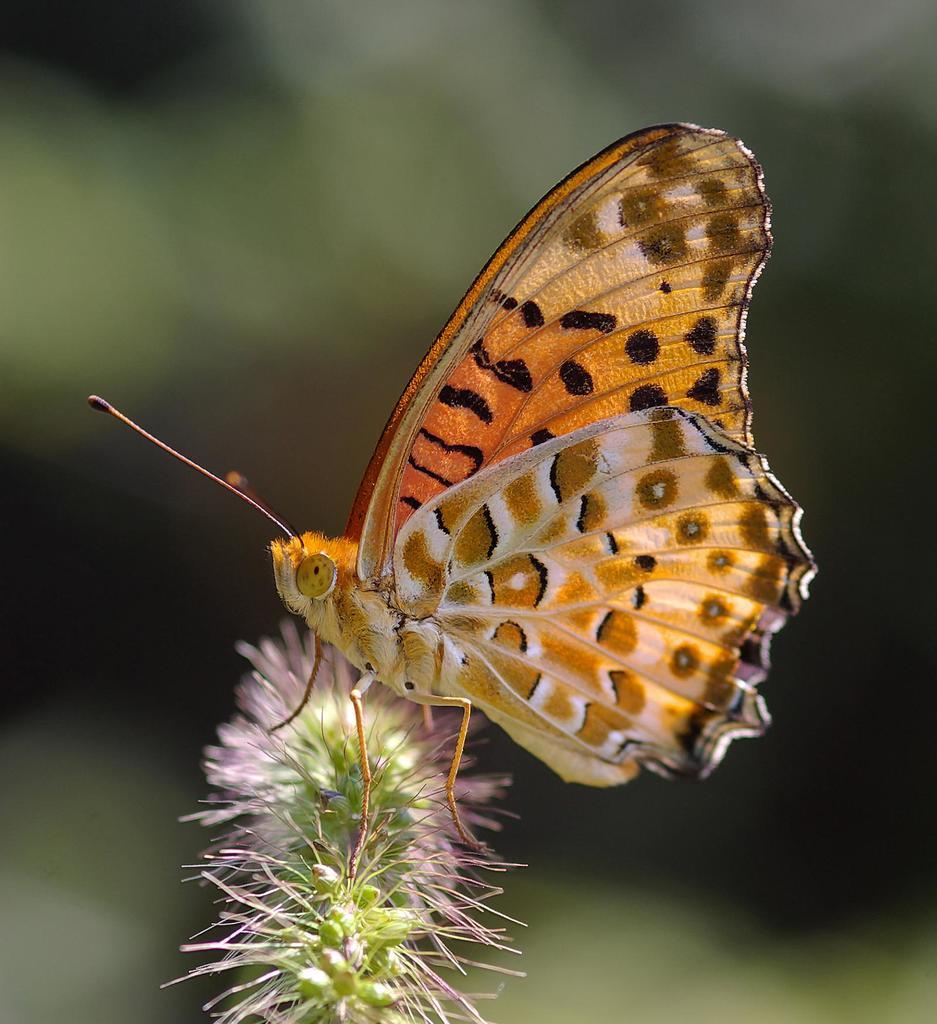What is the main subject of the image? The main subject of the image is a butterfly on a plant. Can you describe the background of the image? The background of the image is blurred. What type of harmony can be heard in the background of the image? There is no audible harmony in the image, as it is a still photograph featuring a butterfly on a plant. 